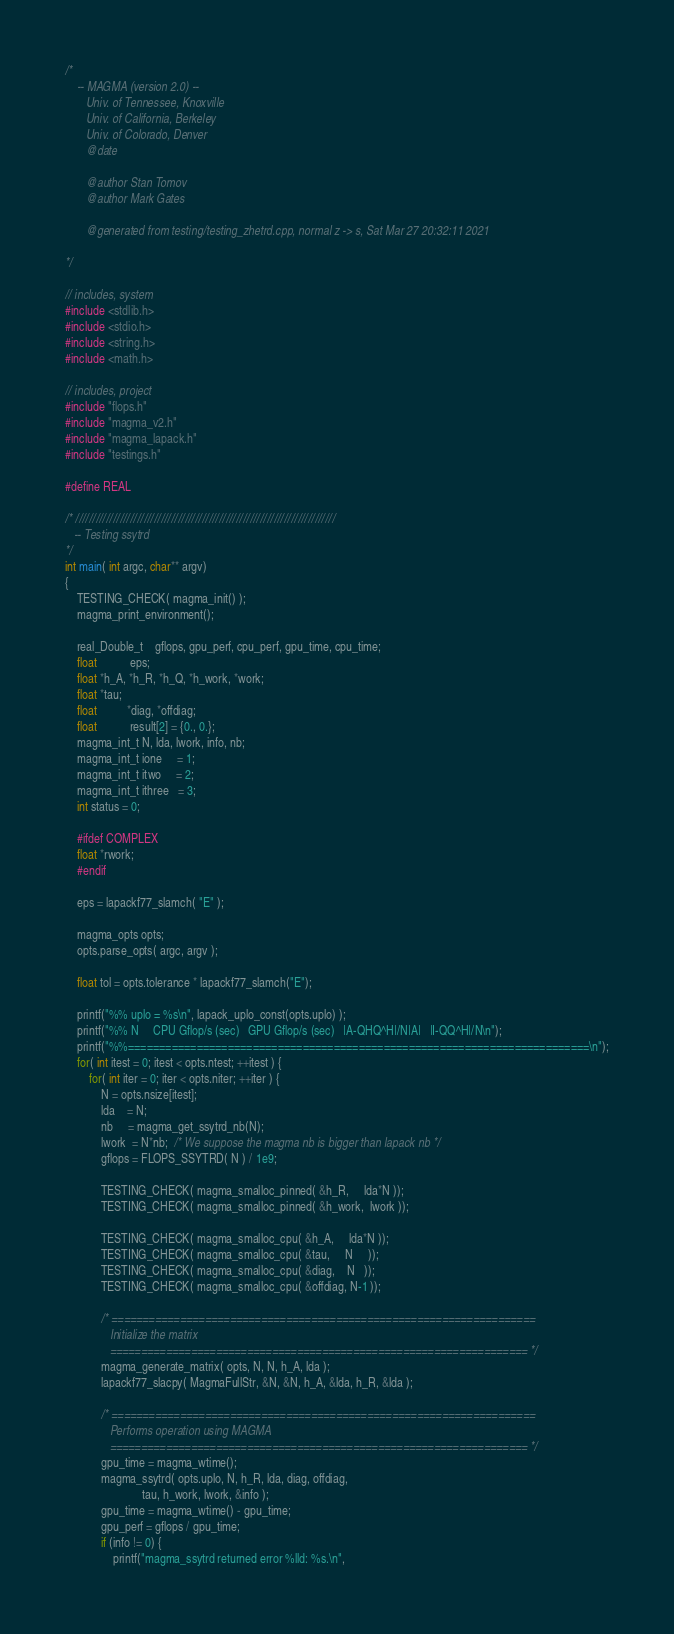Convert code to text. <code><loc_0><loc_0><loc_500><loc_500><_C++_>/*
    -- MAGMA (version 2.0) --
       Univ. of Tennessee, Knoxville
       Univ. of California, Berkeley
       Univ. of Colorado, Denver
       @date

       @author Stan Tomov
       @author Mark Gates

       @generated from testing/testing_zhetrd.cpp, normal z -> s, Sat Mar 27 20:32:11 2021

*/

// includes, system
#include <stdlib.h>
#include <stdio.h>
#include <string.h>
#include <math.h>

// includes, project
#include "flops.h"
#include "magma_v2.h"
#include "magma_lapack.h"
#include "testings.h"

#define REAL

/* ////////////////////////////////////////////////////////////////////////////
   -- Testing ssytrd
*/
int main( int argc, char** argv)
{
    TESTING_CHECK( magma_init() );
    magma_print_environment();

    real_Double_t    gflops, gpu_perf, cpu_perf, gpu_time, cpu_time;
    float           eps;
    float *h_A, *h_R, *h_Q, *h_work, *work;
    float *tau;
    float          *diag, *offdiag;
    float           result[2] = {0., 0.};
    magma_int_t N, lda, lwork, info, nb;
    magma_int_t ione     = 1;
    magma_int_t itwo     = 2;
    magma_int_t ithree   = 3;
    int status = 0;
    
    #ifdef COMPLEX
    float *rwork;
    #endif

    eps = lapackf77_slamch( "E" );

    magma_opts opts;
    opts.parse_opts( argc, argv );
    
    float tol = opts.tolerance * lapackf77_slamch("E");

    printf("%% uplo = %s\n", lapack_uplo_const(opts.uplo) );
    printf("%% N     CPU Gflop/s (sec)   GPU Gflop/s (sec)   |A-QHQ^H|/N|A|   |I-QQ^H|/N\n");
    printf("%%==========================================================================\n");
    for( int itest = 0; itest < opts.ntest; ++itest ) {
        for( int iter = 0; iter < opts.niter; ++iter ) {
            N = opts.nsize[itest];
            lda    = N;
            nb     = magma_get_ssytrd_nb(N);
            lwork  = N*nb;  /* We suppose the magma nb is bigger than lapack nb */
            gflops = FLOPS_SSYTRD( N ) / 1e9;
            
            TESTING_CHECK( magma_smalloc_pinned( &h_R,     lda*N ));
            TESTING_CHECK( magma_smalloc_pinned( &h_work,  lwork ));
            
            TESTING_CHECK( magma_smalloc_cpu( &h_A,     lda*N ));
            TESTING_CHECK( magma_smalloc_cpu( &tau,     N     ));
            TESTING_CHECK( magma_smalloc_cpu( &diag,    N   ));
            TESTING_CHECK( magma_smalloc_cpu( &offdiag, N-1 ));
            
            /* ====================================================================
               Initialize the matrix
               =================================================================== */
            magma_generate_matrix( opts, N, N, h_A, lda );
            lapackf77_slacpy( MagmaFullStr, &N, &N, h_A, &lda, h_R, &lda );
            
            /* ====================================================================
               Performs operation using MAGMA
               =================================================================== */
            gpu_time = magma_wtime();
            magma_ssytrd( opts.uplo, N, h_R, lda, diag, offdiag,
                          tau, h_work, lwork, &info );
            gpu_time = magma_wtime() - gpu_time;
            gpu_perf = gflops / gpu_time;
            if (info != 0) {
                printf("magma_ssytrd returned error %lld: %s.\n",</code> 